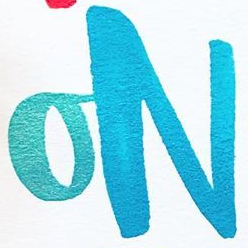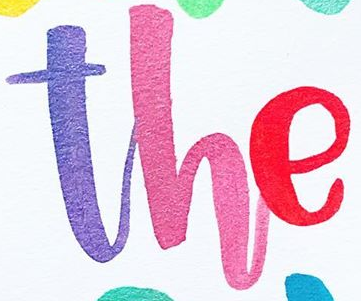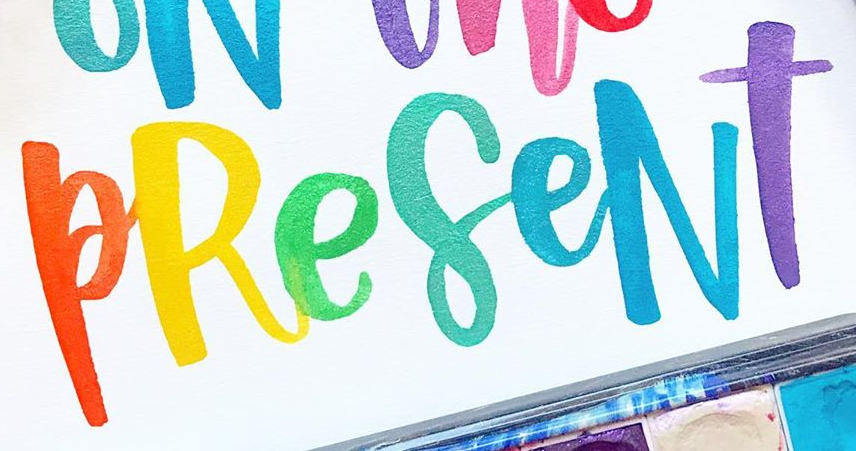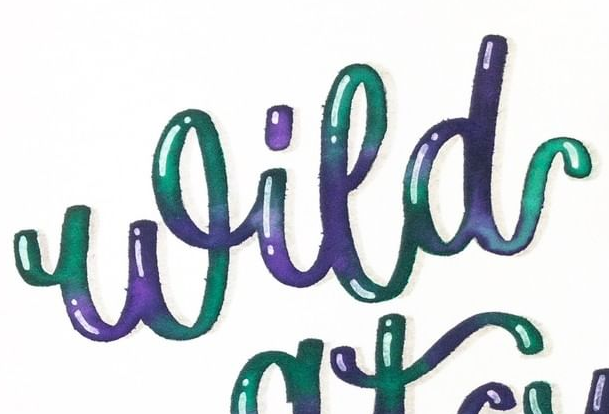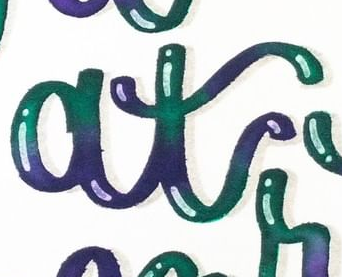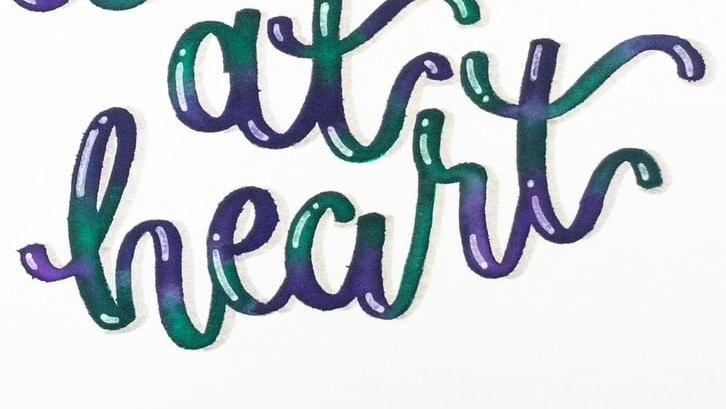What words are shown in these images in order, separated by a semicolon? ON; The; PReseNT; Wild; at; heart 